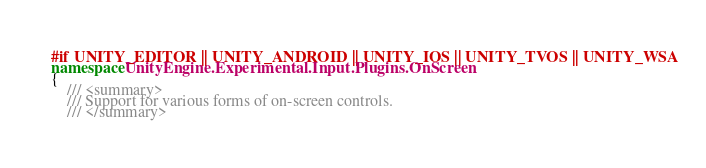Convert code to text. <code><loc_0><loc_0><loc_500><loc_500><_C#_>#if UNITY_EDITOR || UNITY_ANDROID || UNITY_IOS || UNITY_TVOS || UNITY_WSA
namespace UnityEngine.Experimental.Input.Plugins.OnScreen
{
    /// <summary>
    /// Support for various forms of on-screen controls.
    /// </summary></code> 